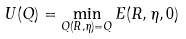<formula> <loc_0><loc_0><loc_500><loc_500>U ( { Q } ) = \min _ { { Q } ( { R } , \eta ) = { Q } } E ( { R } , \eta , 0 )</formula> 